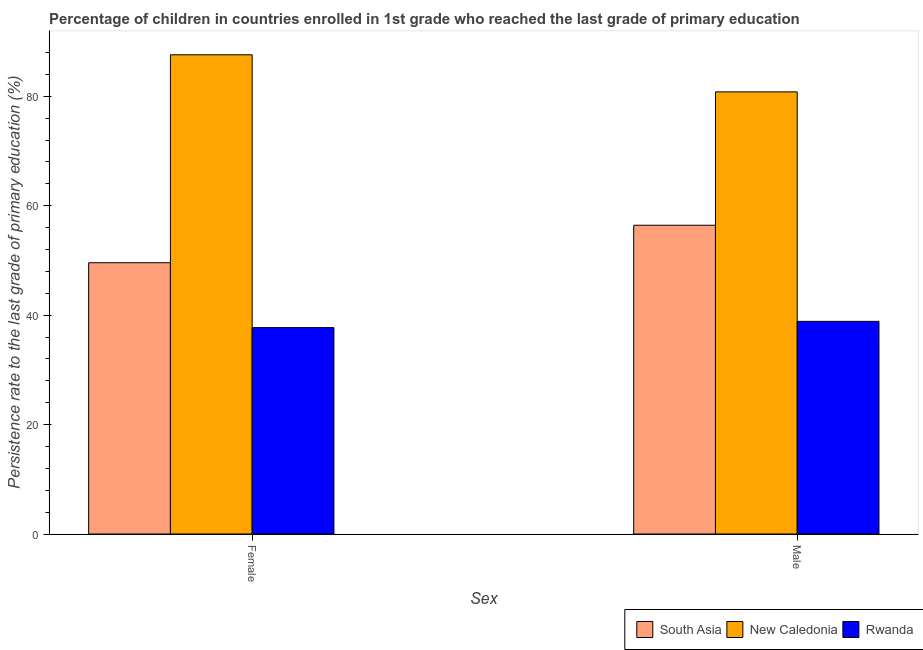How many different coloured bars are there?
Your response must be concise. 3. Are the number of bars per tick equal to the number of legend labels?
Your response must be concise. Yes. Are the number of bars on each tick of the X-axis equal?
Your answer should be compact. Yes. How many bars are there on the 1st tick from the left?
Your response must be concise. 3. What is the label of the 1st group of bars from the left?
Offer a very short reply. Female. What is the persistence rate of female students in New Caledonia?
Offer a terse response. 87.58. Across all countries, what is the maximum persistence rate of female students?
Make the answer very short. 87.58. Across all countries, what is the minimum persistence rate of female students?
Offer a terse response. 37.72. In which country was the persistence rate of male students maximum?
Your answer should be compact. New Caledonia. In which country was the persistence rate of female students minimum?
Provide a succinct answer. Rwanda. What is the total persistence rate of female students in the graph?
Provide a short and direct response. 174.87. What is the difference between the persistence rate of male students in Rwanda and that in South Asia?
Ensure brevity in your answer.  -17.56. What is the difference between the persistence rate of female students in South Asia and the persistence rate of male students in New Caledonia?
Offer a very short reply. -31.22. What is the average persistence rate of male students per country?
Your answer should be compact. 58.7. What is the difference between the persistence rate of female students and persistence rate of male students in New Caledonia?
Your answer should be compact. 6.78. In how many countries, is the persistence rate of female students greater than 40 %?
Make the answer very short. 2. What is the ratio of the persistence rate of female students in New Caledonia to that in South Asia?
Your response must be concise. 1.77. What does the 2nd bar from the left in Female represents?
Make the answer very short. New Caledonia. What does the 3rd bar from the right in Male represents?
Make the answer very short. South Asia. How many bars are there?
Offer a very short reply. 6. Are all the bars in the graph horizontal?
Your answer should be compact. No. How many countries are there in the graph?
Make the answer very short. 3. What is the difference between two consecutive major ticks on the Y-axis?
Give a very brief answer. 20. Are the values on the major ticks of Y-axis written in scientific E-notation?
Offer a terse response. No. Where does the legend appear in the graph?
Keep it short and to the point. Bottom right. What is the title of the graph?
Keep it short and to the point. Percentage of children in countries enrolled in 1st grade who reached the last grade of primary education. What is the label or title of the X-axis?
Offer a terse response. Sex. What is the label or title of the Y-axis?
Your response must be concise. Persistence rate to the last grade of primary education (%). What is the Persistence rate to the last grade of primary education (%) in South Asia in Female?
Give a very brief answer. 49.58. What is the Persistence rate to the last grade of primary education (%) in New Caledonia in Female?
Offer a very short reply. 87.58. What is the Persistence rate to the last grade of primary education (%) in Rwanda in Female?
Your answer should be very brief. 37.72. What is the Persistence rate to the last grade of primary education (%) in South Asia in Male?
Offer a very short reply. 56.43. What is the Persistence rate to the last grade of primary education (%) of New Caledonia in Male?
Offer a very short reply. 80.8. What is the Persistence rate to the last grade of primary education (%) in Rwanda in Male?
Make the answer very short. 38.86. Across all Sex, what is the maximum Persistence rate to the last grade of primary education (%) in South Asia?
Keep it short and to the point. 56.43. Across all Sex, what is the maximum Persistence rate to the last grade of primary education (%) of New Caledonia?
Make the answer very short. 87.58. Across all Sex, what is the maximum Persistence rate to the last grade of primary education (%) of Rwanda?
Your response must be concise. 38.86. Across all Sex, what is the minimum Persistence rate to the last grade of primary education (%) of South Asia?
Your answer should be very brief. 49.58. Across all Sex, what is the minimum Persistence rate to the last grade of primary education (%) of New Caledonia?
Your answer should be very brief. 80.8. Across all Sex, what is the minimum Persistence rate to the last grade of primary education (%) in Rwanda?
Keep it short and to the point. 37.72. What is the total Persistence rate to the last grade of primary education (%) of South Asia in the graph?
Your response must be concise. 106. What is the total Persistence rate to the last grade of primary education (%) in New Caledonia in the graph?
Make the answer very short. 168.38. What is the total Persistence rate to the last grade of primary education (%) in Rwanda in the graph?
Keep it short and to the point. 76.58. What is the difference between the Persistence rate to the last grade of primary education (%) of South Asia in Female and that in Male?
Offer a terse response. -6.85. What is the difference between the Persistence rate to the last grade of primary education (%) of New Caledonia in Female and that in Male?
Ensure brevity in your answer.  6.78. What is the difference between the Persistence rate to the last grade of primary education (%) in Rwanda in Female and that in Male?
Provide a short and direct response. -1.14. What is the difference between the Persistence rate to the last grade of primary education (%) in South Asia in Female and the Persistence rate to the last grade of primary education (%) in New Caledonia in Male?
Make the answer very short. -31.22. What is the difference between the Persistence rate to the last grade of primary education (%) of South Asia in Female and the Persistence rate to the last grade of primary education (%) of Rwanda in Male?
Keep it short and to the point. 10.71. What is the difference between the Persistence rate to the last grade of primary education (%) in New Caledonia in Female and the Persistence rate to the last grade of primary education (%) in Rwanda in Male?
Ensure brevity in your answer.  48.72. What is the average Persistence rate to the last grade of primary education (%) of South Asia per Sex?
Provide a succinct answer. 53. What is the average Persistence rate to the last grade of primary education (%) of New Caledonia per Sex?
Offer a very short reply. 84.19. What is the average Persistence rate to the last grade of primary education (%) in Rwanda per Sex?
Provide a short and direct response. 38.29. What is the difference between the Persistence rate to the last grade of primary education (%) in South Asia and Persistence rate to the last grade of primary education (%) in New Caledonia in Female?
Provide a short and direct response. -38. What is the difference between the Persistence rate to the last grade of primary education (%) in South Asia and Persistence rate to the last grade of primary education (%) in Rwanda in Female?
Provide a succinct answer. 11.86. What is the difference between the Persistence rate to the last grade of primary education (%) of New Caledonia and Persistence rate to the last grade of primary education (%) of Rwanda in Female?
Offer a terse response. 49.86. What is the difference between the Persistence rate to the last grade of primary education (%) of South Asia and Persistence rate to the last grade of primary education (%) of New Caledonia in Male?
Provide a short and direct response. -24.37. What is the difference between the Persistence rate to the last grade of primary education (%) of South Asia and Persistence rate to the last grade of primary education (%) of Rwanda in Male?
Give a very brief answer. 17.56. What is the difference between the Persistence rate to the last grade of primary education (%) in New Caledonia and Persistence rate to the last grade of primary education (%) in Rwanda in Male?
Your answer should be very brief. 41.94. What is the ratio of the Persistence rate to the last grade of primary education (%) in South Asia in Female to that in Male?
Ensure brevity in your answer.  0.88. What is the ratio of the Persistence rate to the last grade of primary education (%) in New Caledonia in Female to that in Male?
Offer a terse response. 1.08. What is the ratio of the Persistence rate to the last grade of primary education (%) in Rwanda in Female to that in Male?
Ensure brevity in your answer.  0.97. What is the difference between the highest and the second highest Persistence rate to the last grade of primary education (%) in South Asia?
Provide a short and direct response. 6.85. What is the difference between the highest and the second highest Persistence rate to the last grade of primary education (%) of New Caledonia?
Your answer should be compact. 6.78. What is the difference between the highest and the second highest Persistence rate to the last grade of primary education (%) in Rwanda?
Give a very brief answer. 1.14. What is the difference between the highest and the lowest Persistence rate to the last grade of primary education (%) of South Asia?
Provide a succinct answer. 6.85. What is the difference between the highest and the lowest Persistence rate to the last grade of primary education (%) of New Caledonia?
Your response must be concise. 6.78. What is the difference between the highest and the lowest Persistence rate to the last grade of primary education (%) in Rwanda?
Your response must be concise. 1.14. 